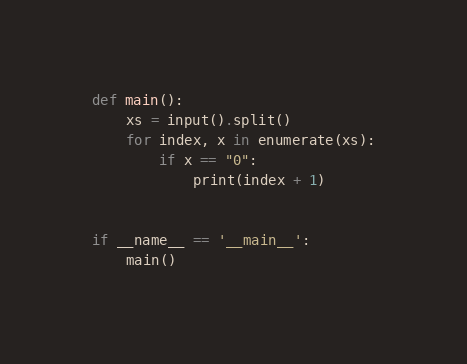Convert code to text. <code><loc_0><loc_0><loc_500><loc_500><_Python_>def main():
    xs = input().split()
    for index, x in enumerate(xs):
        if x == "0":
            print(index + 1)
 
 
if __name__ == '__main__':
    main()</code> 